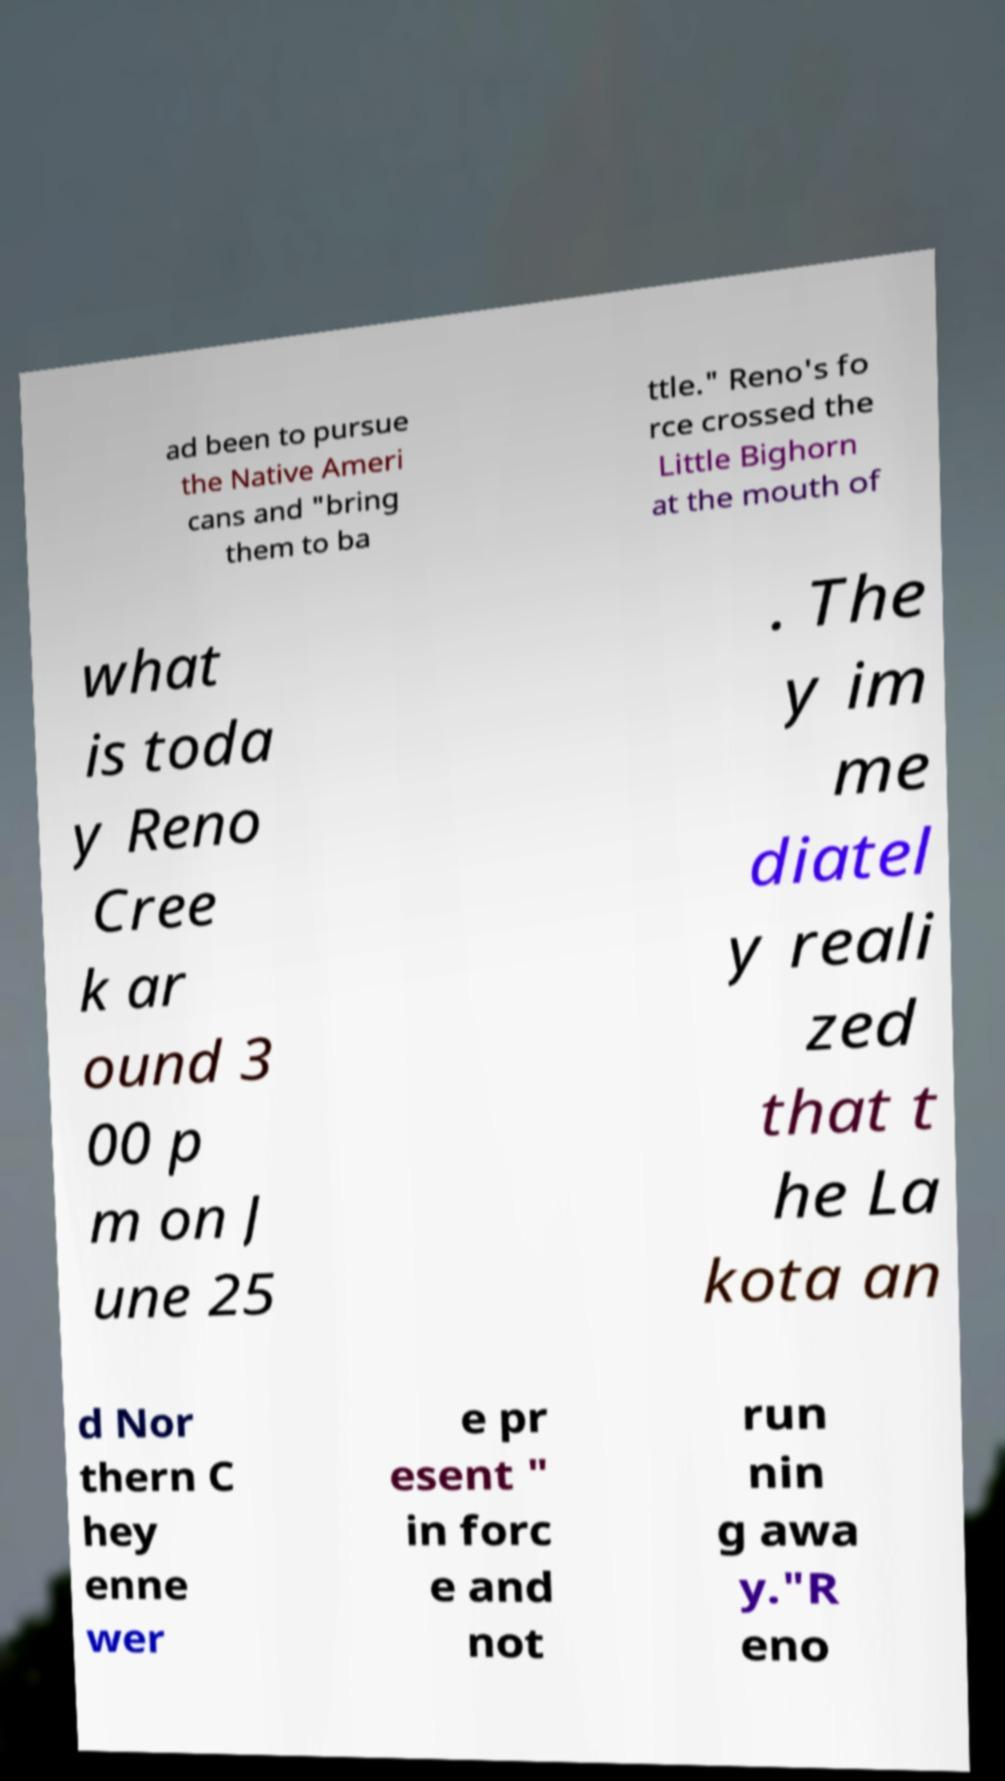Can you read and provide the text displayed in the image?This photo seems to have some interesting text. Can you extract and type it out for me? ad been to pursue the Native Ameri cans and "bring them to ba ttle." Reno's fo rce crossed the Little Bighorn at the mouth of what is toda y Reno Cree k ar ound 3 00 p m on J une 25 . The y im me diatel y reali zed that t he La kota an d Nor thern C hey enne wer e pr esent " in forc e and not run nin g awa y."R eno 